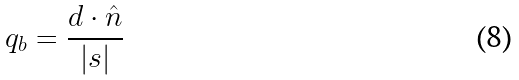<formula> <loc_0><loc_0><loc_500><loc_500>q _ { b } = \frac { d \cdot \hat { n } } { | s | }</formula> 